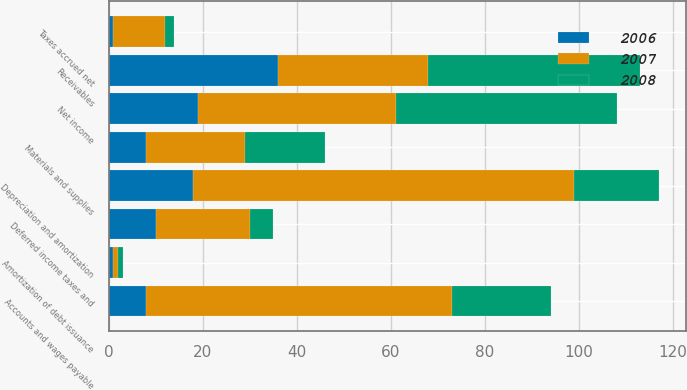<chart> <loc_0><loc_0><loc_500><loc_500><stacked_bar_chart><ecel><fcel>Net income<fcel>Depreciation and amortization<fcel>Amortization of debt issuance<fcel>Deferred income taxes and<fcel>Receivables<fcel>Materials and supplies<fcel>Accounts and wages payable<fcel>Taxes accrued net<nl><fcel>2007<fcel>42<fcel>81<fcel>1<fcel>20<fcel>32<fcel>21<fcel>65<fcel>11<nl><fcel>2008<fcel>47<fcel>18<fcel>1<fcel>5<fcel>45<fcel>17<fcel>21<fcel>2<nl><fcel>2006<fcel>19<fcel>18<fcel>1<fcel>10<fcel>36<fcel>8<fcel>8<fcel>1<nl></chart> 